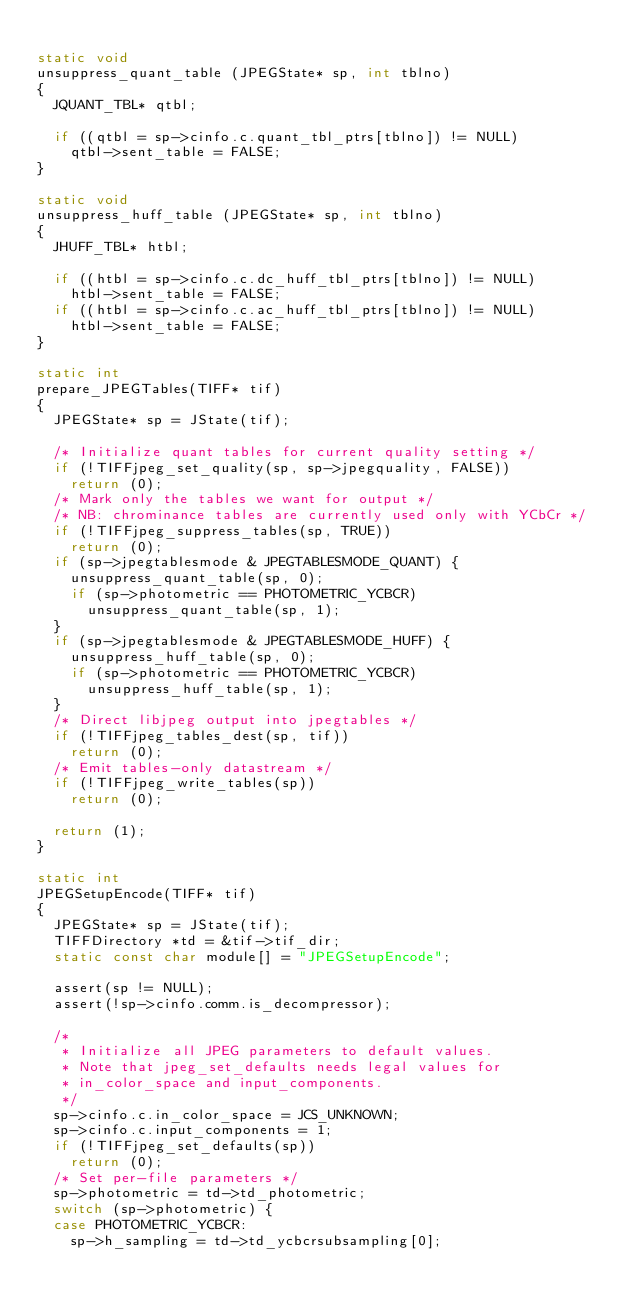<code> <loc_0><loc_0><loc_500><loc_500><_C_>
static void
unsuppress_quant_table (JPEGState* sp, int tblno)
{
	JQUANT_TBL* qtbl;

	if ((qtbl = sp->cinfo.c.quant_tbl_ptrs[tblno]) != NULL)
		qtbl->sent_table = FALSE;
}

static void
unsuppress_huff_table (JPEGState* sp, int tblno)
{
	JHUFF_TBL* htbl;

	if ((htbl = sp->cinfo.c.dc_huff_tbl_ptrs[tblno]) != NULL)
		htbl->sent_table = FALSE;
	if ((htbl = sp->cinfo.c.ac_huff_tbl_ptrs[tblno]) != NULL)
		htbl->sent_table = FALSE;
}

static int
prepare_JPEGTables(TIFF* tif)
{
	JPEGState* sp = JState(tif);

	/* Initialize quant tables for current quality setting */
	if (!TIFFjpeg_set_quality(sp, sp->jpegquality, FALSE))
		return (0);
	/* Mark only the tables we want for output */
	/* NB: chrominance tables are currently used only with YCbCr */
	if (!TIFFjpeg_suppress_tables(sp, TRUE))
		return (0);
	if (sp->jpegtablesmode & JPEGTABLESMODE_QUANT) {
		unsuppress_quant_table(sp, 0);
		if (sp->photometric == PHOTOMETRIC_YCBCR)
			unsuppress_quant_table(sp, 1);
	}
	if (sp->jpegtablesmode & JPEGTABLESMODE_HUFF) {
		unsuppress_huff_table(sp, 0);
		if (sp->photometric == PHOTOMETRIC_YCBCR)
			unsuppress_huff_table(sp, 1);
	}
	/* Direct libjpeg output into jpegtables */
	if (!TIFFjpeg_tables_dest(sp, tif))
		return (0);
	/* Emit tables-only datastream */
	if (!TIFFjpeg_write_tables(sp))
		return (0);

	return (1);
}

static int
JPEGSetupEncode(TIFF* tif)
{
	JPEGState* sp = JState(tif);
	TIFFDirectory *td = &tif->tif_dir;
	static const char module[] = "JPEGSetupEncode";

	assert(sp != NULL);
	assert(!sp->cinfo.comm.is_decompressor);

	/*
	 * Initialize all JPEG parameters to default values.
	 * Note that jpeg_set_defaults needs legal values for
	 * in_color_space and input_components.
	 */
	sp->cinfo.c.in_color_space = JCS_UNKNOWN;
	sp->cinfo.c.input_components = 1;
	if (!TIFFjpeg_set_defaults(sp))
		return (0);
	/* Set per-file parameters */
	sp->photometric = td->td_photometric;
	switch (sp->photometric) {
	case PHOTOMETRIC_YCBCR:
		sp->h_sampling = td->td_ycbcrsubsampling[0];</code> 